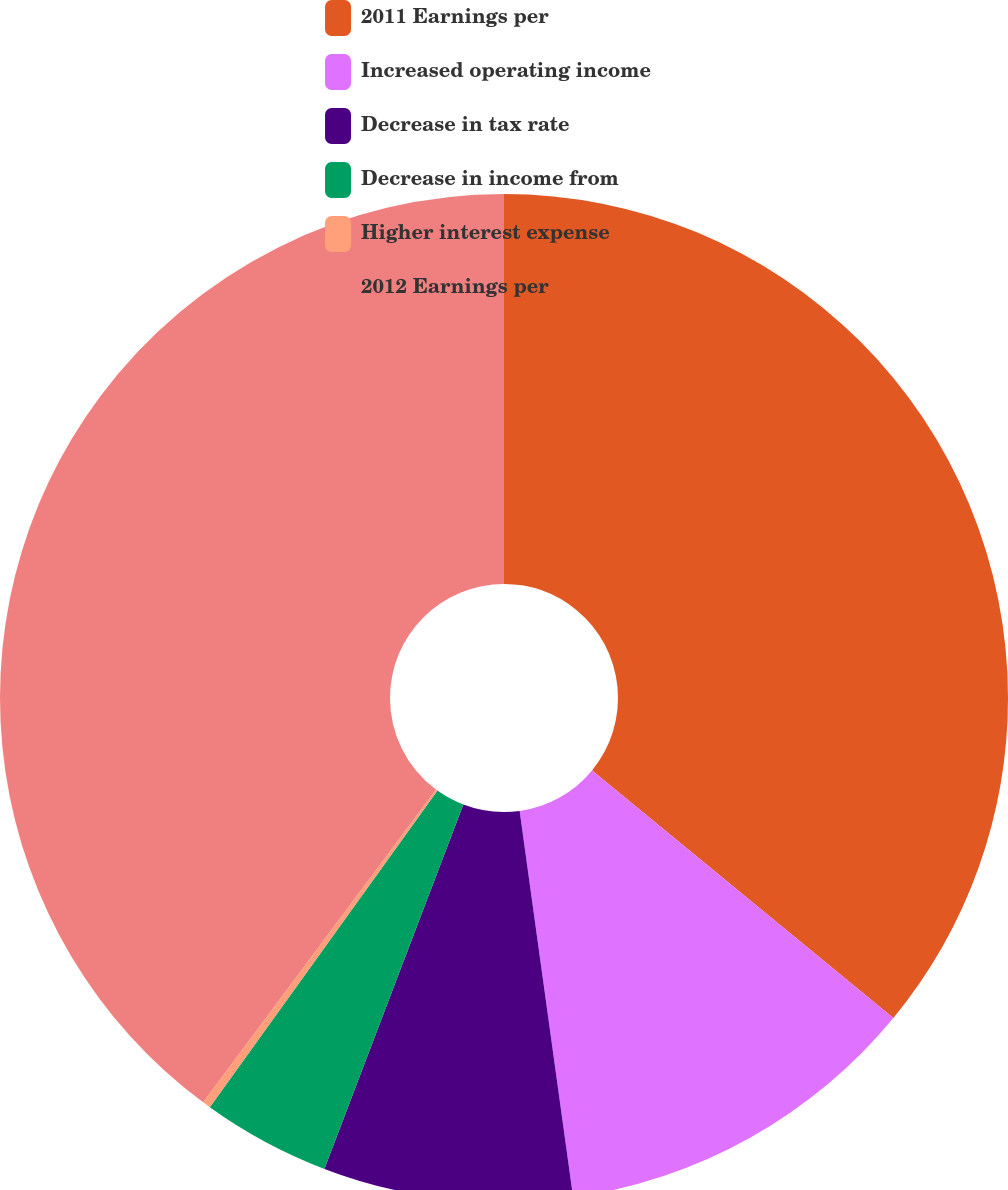Convert chart. <chart><loc_0><loc_0><loc_500><loc_500><pie_chart><fcel>2011 Earnings per<fcel>Increased operating income<fcel>Decrease in tax rate<fcel>Decrease in income from<fcel>Higher interest expense<fcel>2012 Earnings per<nl><fcel>35.95%<fcel>11.86%<fcel>7.99%<fcel>4.12%<fcel>0.26%<fcel>39.82%<nl></chart> 